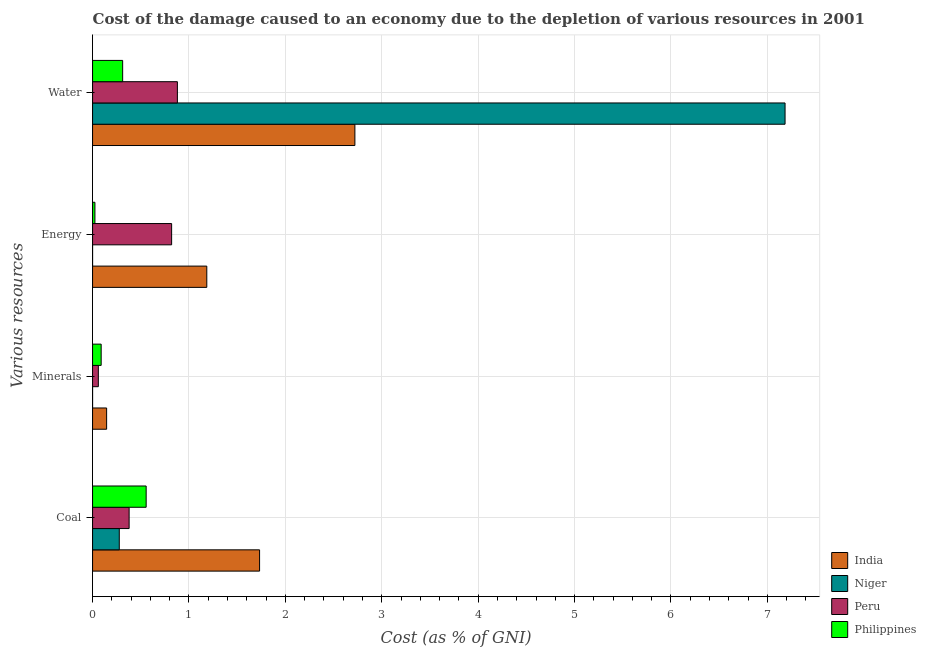How many different coloured bars are there?
Provide a succinct answer. 4. How many groups of bars are there?
Your answer should be very brief. 4. Are the number of bars per tick equal to the number of legend labels?
Your answer should be very brief. Yes. What is the label of the 4th group of bars from the top?
Your answer should be very brief. Coal. What is the cost of damage due to depletion of minerals in Niger?
Your answer should be very brief. 0. Across all countries, what is the maximum cost of damage due to depletion of minerals?
Make the answer very short. 0.15. Across all countries, what is the minimum cost of damage due to depletion of minerals?
Offer a very short reply. 0. In which country was the cost of damage due to depletion of water maximum?
Provide a succinct answer. Niger. In which country was the cost of damage due to depletion of energy minimum?
Give a very brief answer. Niger. What is the total cost of damage due to depletion of energy in the graph?
Make the answer very short. 2.03. What is the difference between the cost of damage due to depletion of minerals in Philippines and that in Peru?
Provide a short and direct response. 0.03. What is the difference between the cost of damage due to depletion of energy in Philippines and the cost of damage due to depletion of coal in India?
Offer a very short reply. -1.71. What is the average cost of damage due to depletion of minerals per country?
Give a very brief answer. 0.07. What is the difference between the cost of damage due to depletion of coal and cost of damage due to depletion of minerals in Peru?
Your answer should be very brief. 0.32. What is the ratio of the cost of damage due to depletion of coal in Niger to that in India?
Your answer should be very brief. 0.16. Is the difference between the cost of damage due to depletion of water in Niger and Philippines greater than the difference between the cost of damage due to depletion of energy in Niger and Philippines?
Give a very brief answer. Yes. What is the difference between the highest and the second highest cost of damage due to depletion of coal?
Provide a short and direct response. 1.18. What is the difference between the highest and the lowest cost of damage due to depletion of minerals?
Offer a very short reply. 0.15. Is the sum of the cost of damage due to depletion of coal in Peru and Niger greater than the maximum cost of damage due to depletion of energy across all countries?
Offer a very short reply. No. What does the 1st bar from the top in Water represents?
Offer a very short reply. Philippines. What does the 2nd bar from the bottom in Coal represents?
Your answer should be very brief. Niger. How many bars are there?
Make the answer very short. 16. How many countries are there in the graph?
Give a very brief answer. 4. Does the graph contain any zero values?
Keep it short and to the point. No. Does the graph contain grids?
Provide a succinct answer. Yes. How many legend labels are there?
Make the answer very short. 4. What is the title of the graph?
Your answer should be compact. Cost of the damage caused to an economy due to the depletion of various resources in 2001 . Does "Kenya" appear as one of the legend labels in the graph?
Your answer should be compact. No. What is the label or title of the X-axis?
Make the answer very short. Cost (as % of GNI). What is the label or title of the Y-axis?
Your answer should be very brief. Various resources. What is the Cost (as % of GNI) in India in Coal?
Your response must be concise. 1.73. What is the Cost (as % of GNI) of Niger in Coal?
Give a very brief answer. 0.28. What is the Cost (as % of GNI) of Peru in Coal?
Keep it short and to the point. 0.38. What is the Cost (as % of GNI) in Philippines in Coal?
Give a very brief answer. 0.56. What is the Cost (as % of GNI) in India in Minerals?
Give a very brief answer. 0.15. What is the Cost (as % of GNI) in Niger in Minerals?
Make the answer very short. 0. What is the Cost (as % of GNI) in Peru in Minerals?
Make the answer very short. 0.06. What is the Cost (as % of GNI) of Philippines in Minerals?
Your answer should be very brief. 0.09. What is the Cost (as % of GNI) in India in Energy?
Ensure brevity in your answer.  1.18. What is the Cost (as % of GNI) of Niger in Energy?
Make the answer very short. 9.85081144667955e-5. What is the Cost (as % of GNI) of Peru in Energy?
Keep it short and to the point. 0.82. What is the Cost (as % of GNI) in Philippines in Energy?
Offer a very short reply. 0.02. What is the Cost (as % of GNI) of India in Water?
Make the answer very short. 2.72. What is the Cost (as % of GNI) of Niger in Water?
Your answer should be very brief. 7.18. What is the Cost (as % of GNI) of Peru in Water?
Offer a very short reply. 0.88. What is the Cost (as % of GNI) in Philippines in Water?
Ensure brevity in your answer.  0.31. Across all Various resources, what is the maximum Cost (as % of GNI) in India?
Your answer should be compact. 2.72. Across all Various resources, what is the maximum Cost (as % of GNI) of Niger?
Your answer should be compact. 7.18. Across all Various resources, what is the maximum Cost (as % of GNI) in Peru?
Give a very brief answer. 0.88. Across all Various resources, what is the maximum Cost (as % of GNI) of Philippines?
Keep it short and to the point. 0.56. Across all Various resources, what is the minimum Cost (as % of GNI) of India?
Provide a succinct answer. 0.15. Across all Various resources, what is the minimum Cost (as % of GNI) in Niger?
Offer a terse response. 9.85081144667955e-5. Across all Various resources, what is the minimum Cost (as % of GNI) in Peru?
Your answer should be compact. 0.06. Across all Various resources, what is the minimum Cost (as % of GNI) of Philippines?
Make the answer very short. 0.02. What is the total Cost (as % of GNI) of India in the graph?
Your answer should be very brief. 5.78. What is the total Cost (as % of GNI) in Niger in the graph?
Your answer should be compact. 7.46. What is the total Cost (as % of GNI) of Peru in the graph?
Provide a short and direct response. 2.14. What is the total Cost (as % of GNI) of Philippines in the graph?
Your answer should be very brief. 0.98. What is the difference between the Cost (as % of GNI) in India in Coal and that in Minerals?
Your answer should be very brief. 1.59. What is the difference between the Cost (as % of GNI) in Niger in Coal and that in Minerals?
Make the answer very short. 0.28. What is the difference between the Cost (as % of GNI) in Peru in Coal and that in Minerals?
Provide a succinct answer. 0.32. What is the difference between the Cost (as % of GNI) of Philippines in Coal and that in Minerals?
Your answer should be very brief. 0.47. What is the difference between the Cost (as % of GNI) of India in Coal and that in Energy?
Your answer should be very brief. 0.55. What is the difference between the Cost (as % of GNI) in Niger in Coal and that in Energy?
Your answer should be very brief. 0.28. What is the difference between the Cost (as % of GNI) in Peru in Coal and that in Energy?
Offer a terse response. -0.44. What is the difference between the Cost (as % of GNI) in Philippines in Coal and that in Energy?
Offer a very short reply. 0.53. What is the difference between the Cost (as % of GNI) of India in Coal and that in Water?
Provide a short and direct response. -0.99. What is the difference between the Cost (as % of GNI) in Niger in Coal and that in Water?
Offer a terse response. -6.91. What is the difference between the Cost (as % of GNI) in Peru in Coal and that in Water?
Make the answer very short. -0.5. What is the difference between the Cost (as % of GNI) in Philippines in Coal and that in Water?
Make the answer very short. 0.24. What is the difference between the Cost (as % of GNI) of India in Minerals and that in Energy?
Ensure brevity in your answer.  -1.04. What is the difference between the Cost (as % of GNI) in Niger in Minerals and that in Energy?
Offer a terse response. 0. What is the difference between the Cost (as % of GNI) in Peru in Minerals and that in Energy?
Your answer should be very brief. -0.76. What is the difference between the Cost (as % of GNI) in Philippines in Minerals and that in Energy?
Give a very brief answer. 0.06. What is the difference between the Cost (as % of GNI) of India in Minerals and that in Water?
Offer a terse response. -2.58. What is the difference between the Cost (as % of GNI) in Niger in Minerals and that in Water?
Make the answer very short. -7.18. What is the difference between the Cost (as % of GNI) of Peru in Minerals and that in Water?
Provide a short and direct response. -0.82. What is the difference between the Cost (as % of GNI) of Philippines in Minerals and that in Water?
Your answer should be very brief. -0.22. What is the difference between the Cost (as % of GNI) of India in Energy and that in Water?
Your response must be concise. -1.54. What is the difference between the Cost (as % of GNI) of Niger in Energy and that in Water?
Ensure brevity in your answer.  -7.18. What is the difference between the Cost (as % of GNI) of Peru in Energy and that in Water?
Provide a succinct answer. -0.06. What is the difference between the Cost (as % of GNI) of Philippines in Energy and that in Water?
Provide a succinct answer. -0.29. What is the difference between the Cost (as % of GNI) of India in Coal and the Cost (as % of GNI) of Niger in Minerals?
Your answer should be very brief. 1.73. What is the difference between the Cost (as % of GNI) in India in Coal and the Cost (as % of GNI) in Peru in Minerals?
Offer a very short reply. 1.67. What is the difference between the Cost (as % of GNI) in India in Coal and the Cost (as % of GNI) in Philippines in Minerals?
Give a very brief answer. 1.64. What is the difference between the Cost (as % of GNI) in Niger in Coal and the Cost (as % of GNI) in Peru in Minerals?
Your answer should be very brief. 0.22. What is the difference between the Cost (as % of GNI) in Niger in Coal and the Cost (as % of GNI) in Philippines in Minerals?
Ensure brevity in your answer.  0.19. What is the difference between the Cost (as % of GNI) in Peru in Coal and the Cost (as % of GNI) in Philippines in Minerals?
Provide a short and direct response. 0.29. What is the difference between the Cost (as % of GNI) of India in Coal and the Cost (as % of GNI) of Niger in Energy?
Ensure brevity in your answer.  1.73. What is the difference between the Cost (as % of GNI) of India in Coal and the Cost (as % of GNI) of Peru in Energy?
Provide a short and direct response. 0.91. What is the difference between the Cost (as % of GNI) in India in Coal and the Cost (as % of GNI) in Philippines in Energy?
Make the answer very short. 1.71. What is the difference between the Cost (as % of GNI) of Niger in Coal and the Cost (as % of GNI) of Peru in Energy?
Keep it short and to the point. -0.54. What is the difference between the Cost (as % of GNI) in Niger in Coal and the Cost (as % of GNI) in Philippines in Energy?
Your response must be concise. 0.25. What is the difference between the Cost (as % of GNI) of Peru in Coal and the Cost (as % of GNI) of Philippines in Energy?
Make the answer very short. 0.35. What is the difference between the Cost (as % of GNI) of India in Coal and the Cost (as % of GNI) of Niger in Water?
Provide a succinct answer. -5.45. What is the difference between the Cost (as % of GNI) in India in Coal and the Cost (as % of GNI) in Peru in Water?
Your answer should be compact. 0.85. What is the difference between the Cost (as % of GNI) in India in Coal and the Cost (as % of GNI) in Philippines in Water?
Ensure brevity in your answer.  1.42. What is the difference between the Cost (as % of GNI) of Niger in Coal and the Cost (as % of GNI) of Peru in Water?
Make the answer very short. -0.6. What is the difference between the Cost (as % of GNI) of Niger in Coal and the Cost (as % of GNI) of Philippines in Water?
Your answer should be compact. -0.04. What is the difference between the Cost (as % of GNI) in Peru in Coal and the Cost (as % of GNI) in Philippines in Water?
Your answer should be very brief. 0.07. What is the difference between the Cost (as % of GNI) in India in Minerals and the Cost (as % of GNI) in Niger in Energy?
Your answer should be compact. 0.15. What is the difference between the Cost (as % of GNI) in India in Minerals and the Cost (as % of GNI) in Peru in Energy?
Offer a terse response. -0.67. What is the difference between the Cost (as % of GNI) of India in Minerals and the Cost (as % of GNI) of Philippines in Energy?
Make the answer very short. 0.12. What is the difference between the Cost (as % of GNI) of Niger in Minerals and the Cost (as % of GNI) of Peru in Energy?
Ensure brevity in your answer.  -0.82. What is the difference between the Cost (as % of GNI) of Niger in Minerals and the Cost (as % of GNI) of Philippines in Energy?
Ensure brevity in your answer.  -0.02. What is the difference between the Cost (as % of GNI) in Peru in Minerals and the Cost (as % of GNI) in Philippines in Energy?
Offer a terse response. 0.04. What is the difference between the Cost (as % of GNI) in India in Minerals and the Cost (as % of GNI) in Niger in Water?
Offer a terse response. -7.04. What is the difference between the Cost (as % of GNI) of India in Minerals and the Cost (as % of GNI) of Peru in Water?
Provide a succinct answer. -0.73. What is the difference between the Cost (as % of GNI) in India in Minerals and the Cost (as % of GNI) in Philippines in Water?
Provide a short and direct response. -0.17. What is the difference between the Cost (as % of GNI) of Niger in Minerals and the Cost (as % of GNI) of Peru in Water?
Offer a terse response. -0.88. What is the difference between the Cost (as % of GNI) of Niger in Minerals and the Cost (as % of GNI) of Philippines in Water?
Your answer should be compact. -0.31. What is the difference between the Cost (as % of GNI) of Peru in Minerals and the Cost (as % of GNI) of Philippines in Water?
Your response must be concise. -0.25. What is the difference between the Cost (as % of GNI) in India in Energy and the Cost (as % of GNI) in Niger in Water?
Your response must be concise. -6. What is the difference between the Cost (as % of GNI) in India in Energy and the Cost (as % of GNI) in Peru in Water?
Your answer should be compact. 0.3. What is the difference between the Cost (as % of GNI) in India in Energy and the Cost (as % of GNI) in Philippines in Water?
Ensure brevity in your answer.  0.87. What is the difference between the Cost (as % of GNI) of Niger in Energy and the Cost (as % of GNI) of Peru in Water?
Your response must be concise. -0.88. What is the difference between the Cost (as % of GNI) in Niger in Energy and the Cost (as % of GNI) in Philippines in Water?
Offer a terse response. -0.31. What is the difference between the Cost (as % of GNI) in Peru in Energy and the Cost (as % of GNI) in Philippines in Water?
Offer a very short reply. 0.51. What is the average Cost (as % of GNI) in India per Various resources?
Offer a terse response. 1.45. What is the average Cost (as % of GNI) of Niger per Various resources?
Keep it short and to the point. 1.87. What is the average Cost (as % of GNI) of Peru per Various resources?
Offer a terse response. 0.53. What is the average Cost (as % of GNI) in Philippines per Various resources?
Keep it short and to the point. 0.25. What is the difference between the Cost (as % of GNI) in India and Cost (as % of GNI) in Niger in Coal?
Your response must be concise. 1.46. What is the difference between the Cost (as % of GNI) in India and Cost (as % of GNI) in Peru in Coal?
Ensure brevity in your answer.  1.35. What is the difference between the Cost (as % of GNI) in India and Cost (as % of GNI) in Philippines in Coal?
Your answer should be compact. 1.18. What is the difference between the Cost (as % of GNI) in Niger and Cost (as % of GNI) in Peru in Coal?
Your response must be concise. -0.1. What is the difference between the Cost (as % of GNI) in Niger and Cost (as % of GNI) in Philippines in Coal?
Make the answer very short. -0.28. What is the difference between the Cost (as % of GNI) of Peru and Cost (as % of GNI) of Philippines in Coal?
Make the answer very short. -0.18. What is the difference between the Cost (as % of GNI) of India and Cost (as % of GNI) of Niger in Minerals?
Ensure brevity in your answer.  0.15. What is the difference between the Cost (as % of GNI) in India and Cost (as % of GNI) in Peru in Minerals?
Ensure brevity in your answer.  0.09. What is the difference between the Cost (as % of GNI) of India and Cost (as % of GNI) of Philippines in Minerals?
Your answer should be very brief. 0.06. What is the difference between the Cost (as % of GNI) in Niger and Cost (as % of GNI) in Peru in Minerals?
Your answer should be very brief. -0.06. What is the difference between the Cost (as % of GNI) of Niger and Cost (as % of GNI) of Philippines in Minerals?
Provide a succinct answer. -0.09. What is the difference between the Cost (as % of GNI) of Peru and Cost (as % of GNI) of Philippines in Minerals?
Provide a short and direct response. -0.03. What is the difference between the Cost (as % of GNI) of India and Cost (as % of GNI) of Niger in Energy?
Keep it short and to the point. 1.18. What is the difference between the Cost (as % of GNI) in India and Cost (as % of GNI) in Peru in Energy?
Provide a succinct answer. 0.36. What is the difference between the Cost (as % of GNI) in India and Cost (as % of GNI) in Philippines in Energy?
Provide a succinct answer. 1.16. What is the difference between the Cost (as % of GNI) of Niger and Cost (as % of GNI) of Peru in Energy?
Your response must be concise. -0.82. What is the difference between the Cost (as % of GNI) of Niger and Cost (as % of GNI) of Philippines in Energy?
Give a very brief answer. -0.02. What is the difference between the Cost (as % of GNI) in Peru and Cost (as % of GNI) in Philippines in Energy?
Offer a terse response. 0.8. What is the difference between the Cost (as % of GNI) in India and Cost (as % of GNI) in Niger in Water?
Ensure brevity in your answer.  -4.46. What is the difference between the Cost (as % of GNI) in India and Cost (as % of GNI) in Peru in Water?
Your response must be concise. 1.84. What is the difference between the Cost (as % of GNI) of India and Cost (as % of GNI) of Philippines in Water?
Give a very brief answer. 2.41. What is the difference between the Cost (as % of GNI) of Niger and Cost (as % of GNI) of Peru in Water?
Ensure brevity in your answer.  6.3. What is the difference between the Cost (as % of GNI) of Niger and Cost (as % of GNI) of Philippines in Water?
Ensure brevity in your answer.  6.87. What is the difference between the Cost (as % of GNI) of Peru and Cost (as % of GNI) of Philippines in Water?
Offer a very short reply. 0.57. What is the ratio of the Cost (as % of GNI) of India in Coal to that in Minerals?
Keep it short and to the point. 11.88. What is the ratio of the Cost (as % of GNI) of Niger in Coal to that in Minerals?
Give a very brief answer. 1407.12. What is the ratio of the Cost (as % of GNI) of Peru in Coal to that in Minerals?
Make the answer very short. 6.33. What is the ratio of the Cost (as % of GNI) in Philippines in Coal to that in Minerals?
Your answer should be very brief. 6.23. What is the ratio of the Cost (as % of GNI) in India in Coal to that in Energy?
Keep it short and to the point. 1.46. What is the ratio of the Cost (as % of GNI) of Niger in Coal to that in Energy?
Your response must be concise. 2813.4. What is the ratio of the Cost (as % of GNI) of Peru in Coal to that in Energy?
Offer a very short reply. 0.46. What is the ratio of the Cost (as % of GNI) in Philippines in Coal to that in Energy?
Keep it short and to the point. 22.8. What is the ratio of the Cost (as % of GNI) of India in Coal to that in Water?
Offer a very short reply. 0.64. What is the ratio of the Cost (as % of GNI) of Niger in Coal to that in Water?
Provide a short and direct response. 0.04. What is the ratio of the Cost (as % of GNI) in Peru in Coal to that in Water?
Your answer should be very brief. 0.43. What is the ratio of the Cost (as % of GNI) in Philippines in Coal to that in Water?
Keep it short and to the point. 1.78. What is the ratio of the Cost (as % of GNI) in India in Minerals to that in Energy?
Your answer should be very brief. 0.12. What is the ratio of the Cost (as % of GNI) of Niger in Minerals to that in Energy?
Offer a terse response. 2. What is the ratio of the Cost (as % of GNI) in Peru in Minerals to that in Energy?
Offer a terse response. 0.07. What is the ratio of the Cost (as % of GNI) in Philippines in Minerals to that in Energy?
Provide a succinct answer. 3.66. What is the ratio of the Cost (as % of GNI) of India in Minerals to that in Water?
Make the answer very short. 0.05. What is the ratio of the Cost (as % of GNI) of Niger in Minerals to that in Water?
Make the answer very short. 0. What is the ratio of the Cost (as % of GNI) of Peru in Minerals to that in Water?
Offer a terse response. 0.07. What is the ratio of the Cost (as % of GNI) in Philippines in Minerals to that in Water?
Ensure brevity in your answer.  0.29. What is the ratio of the Cost (as % of GNI) in India in Energy to that in Water?
Provide a short and direct response. 0.44. What is the ratio of the Cost (as % of GNI) of Niger in Energy to that in Water?
Your response must be concise. 0. What is the ratio of the Cost (as % of GNI) of Peru in Energy to that in Water?
Offer a very short reply. 0.93. What is the ratio of the Cost (as % of GNI) in Philippines in Energy to that in Water?
Your answer should be compact. 0.08. What is the difference between the highest and the second highest Cost (as % of GNI) of Niger?
Keep it short and to the point. 6.91. What is the difference between the highest and the second highest Cost (as % of GNI) in Peru?
Keep it short and to the point. 0.06. What is the difference between the highest and the second highest Cost (as % of GNI) in Philippines?
Ensure brevity in your answer.  0.24. What is the difference between the highest and the lowest Cost (as % of GNI) of India?
Offer a terse response. 2.58. What is the difference between the highest and the lowest Cost (as % of GNI) in Niger?
Keep it short and to the point. 7.18. What is the difference between the highest and the lowest Cost (as % of GNI) of Peru?
Provide a short and direct response. 0.82. What is the difference between the highest and the lowest Cost (as % of GNI) in Philippines?
Offer a very short reply. 0.53. 